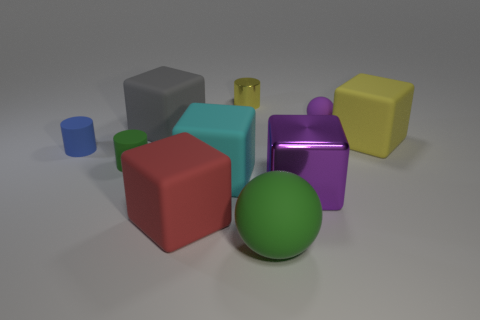How many things are either rubber objects behind the big green matte ball or rubber spheres that are in front of the big metal object?
Ensure brevity in your answer.  8. What color is the small matte thing that is the same shape as the big green thing?
Keep it short and to the point. Purple. Is there anything else that is the same shape as the big red object?
Ensure brevity in your answer.  Yes. There is a cyan thing; does it have the same shape as the large thing left of the red rubber thing?
Ensure brevity in your answer.  Yes. What is the red object made of?
Provide a short and direct response. Rubber. What is the size of the green object that is the same shape as the yellow shiny object?
Offer a very short reply. Small. How many other things are the same material as the green cylinder?
Give a very brief answer. 7. Is the large yellow cube made of the same material as the purple thing in front of the cyan object?
Offer a very short reply. No. Are there fewer big green balls that are right of the yellow block than small rubber cylinders that are on the right side of the small blue cylinder?
Your answer should be compact. Yes. There is a matte ball that is in front of the big red cube; what is its color?
Ensure brevity in your answer.  Green. 